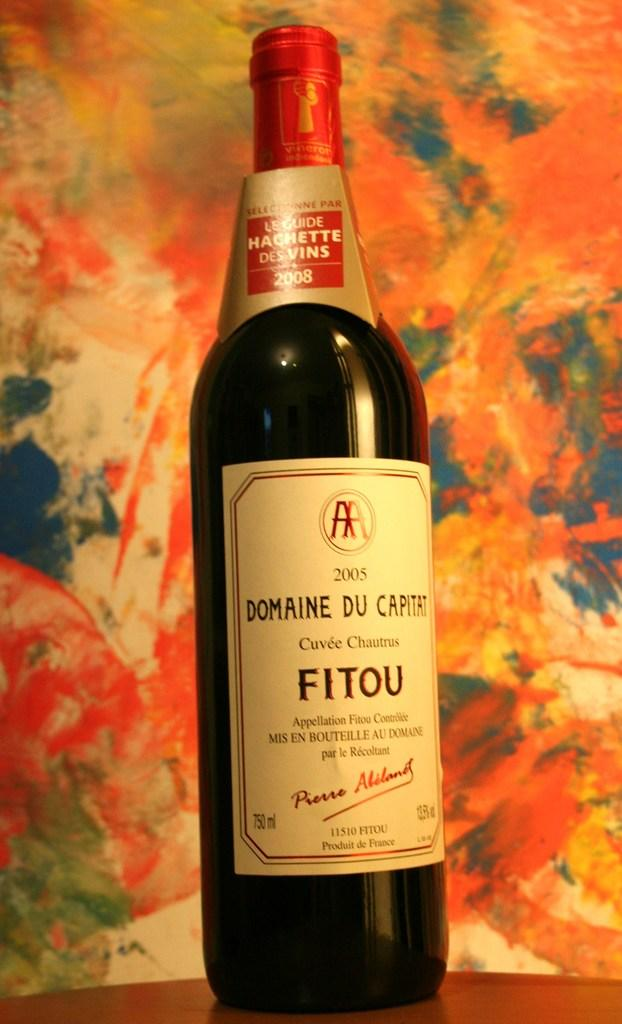<image>
Give a short and clear explanation of the subsequent image. A bottle of Domaine Du Capitat is sitting on a table. 